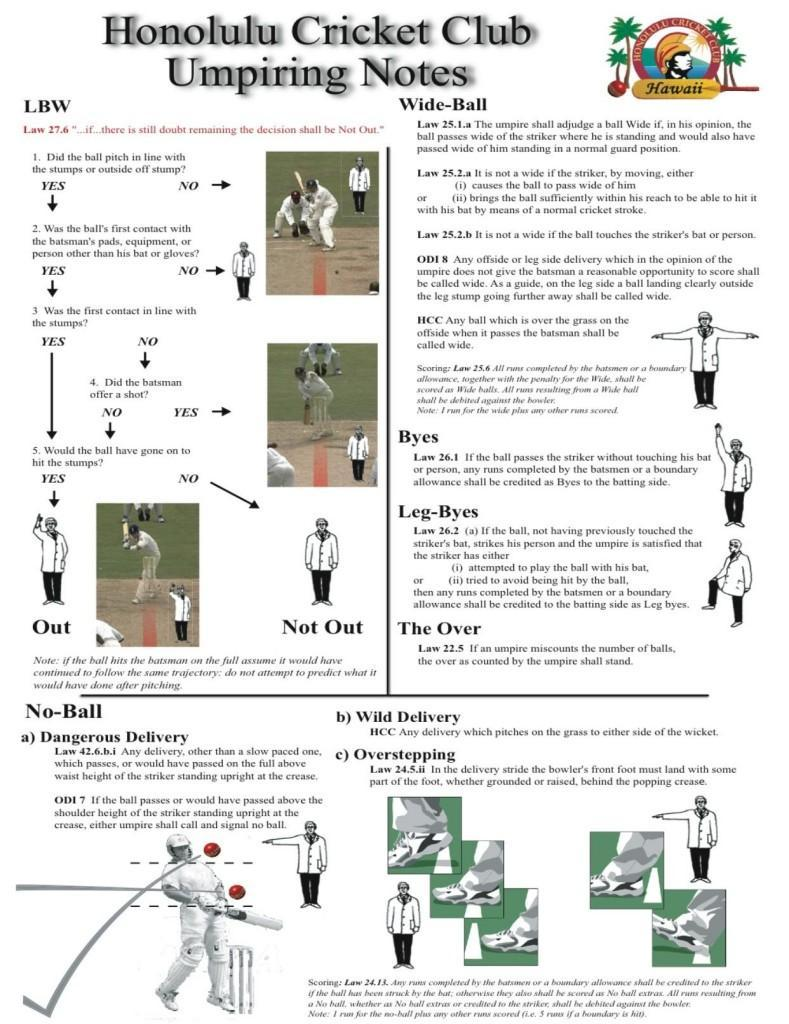Which all ways a ball is called a no-ball?
Answer the question with a short phrase. Dangerous delivery, Wild delivery, Overstepping In how many ways a ball is called a no-ball? 3 